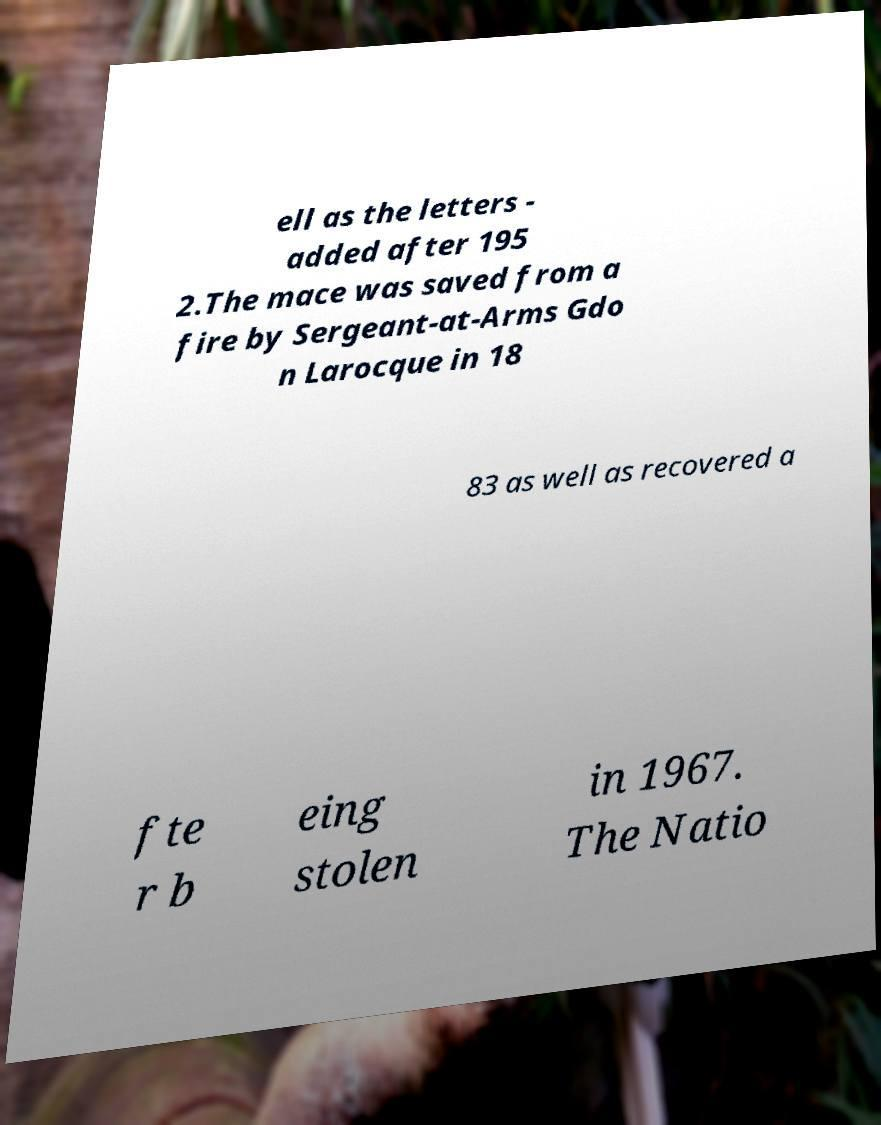Could you extract and type out the text from this image? ell as the letters - added after 195 2.The mace was saved from a fire by Sergeant-at-Arms Gdo n Larocque in 18 83 as well as recovered a fte r b eing stolen in 1967. The Natio 